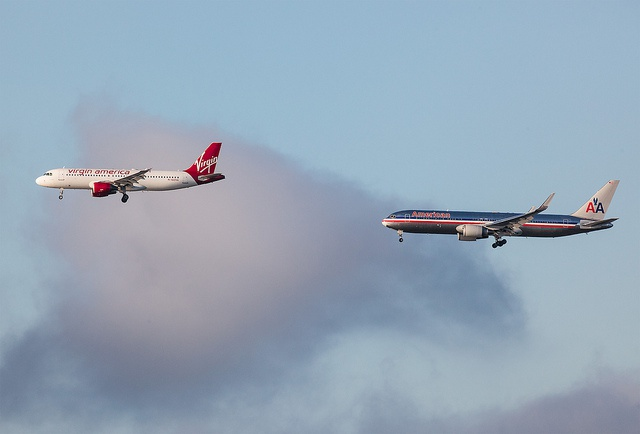Describe the objects in this image and their specific colors. I can see airplane in lightblue, black, darkgray, gray, and blue tones and airplane in lightblue, lightgray, darkgray, gray, and black tones in this image. 